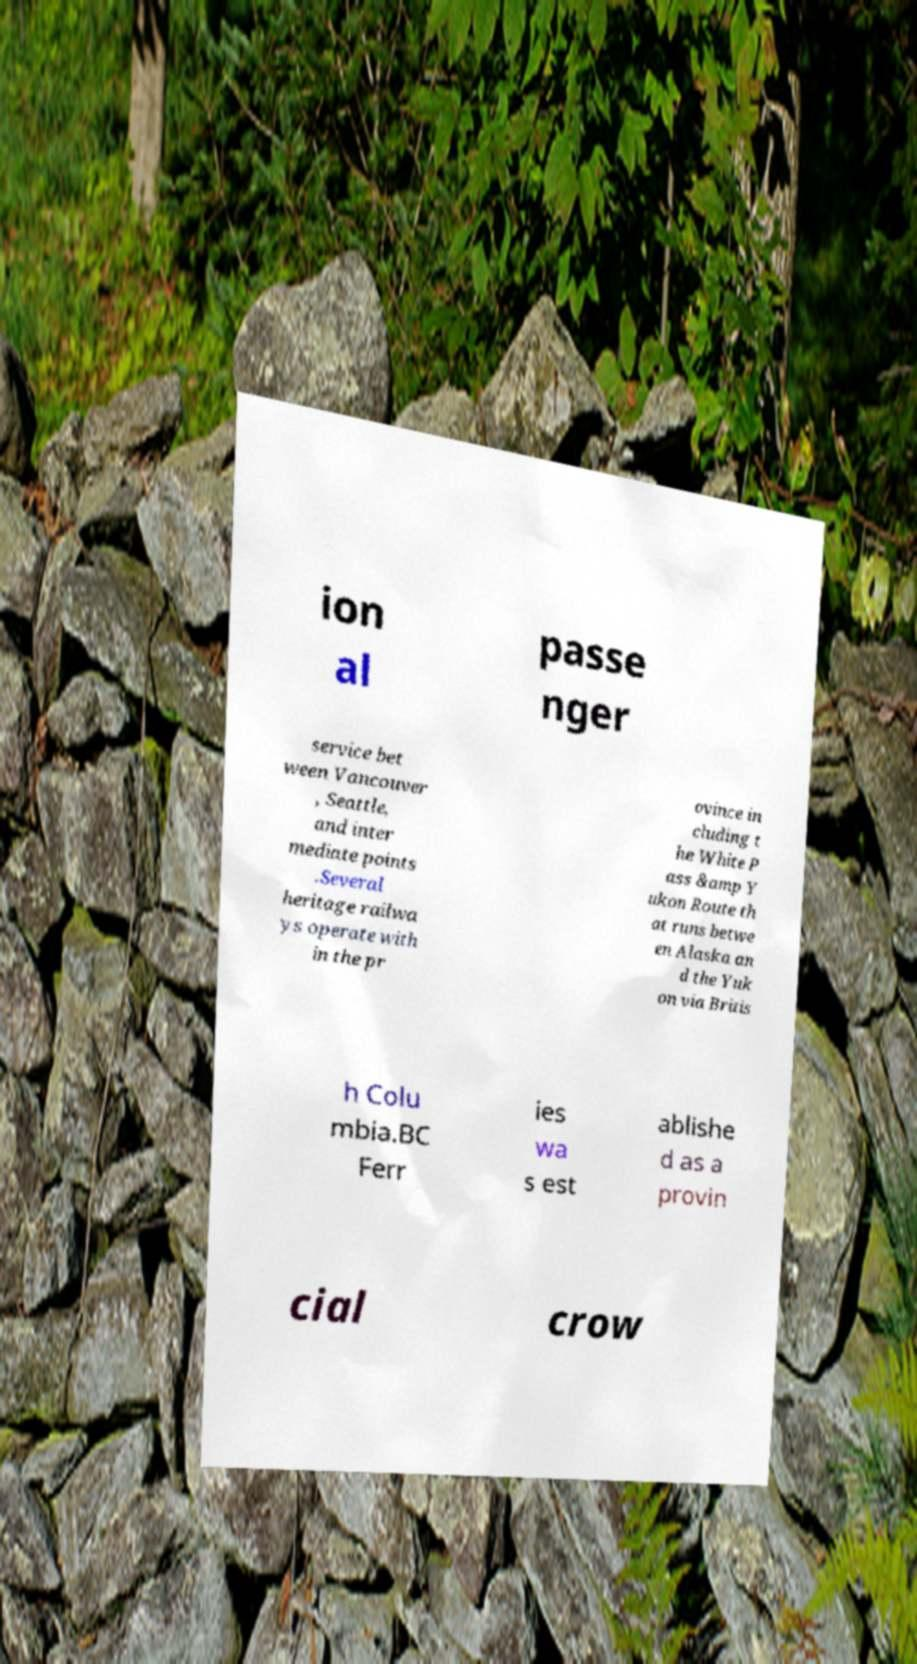Can you accurately transcribe the text from the provided image for me? ion al passe nger service bet ween Vancouver , Seattle, and inter mediate points .Several heritage railwa ys operate with in the pr ovince in cluding t he White P ass &amp Y ukon Route th at runs betwe en Alaska an d the Yuk on via Britis h Colu mbia.BC Ferr ies wa s est ablishe d as a provin cial crow 